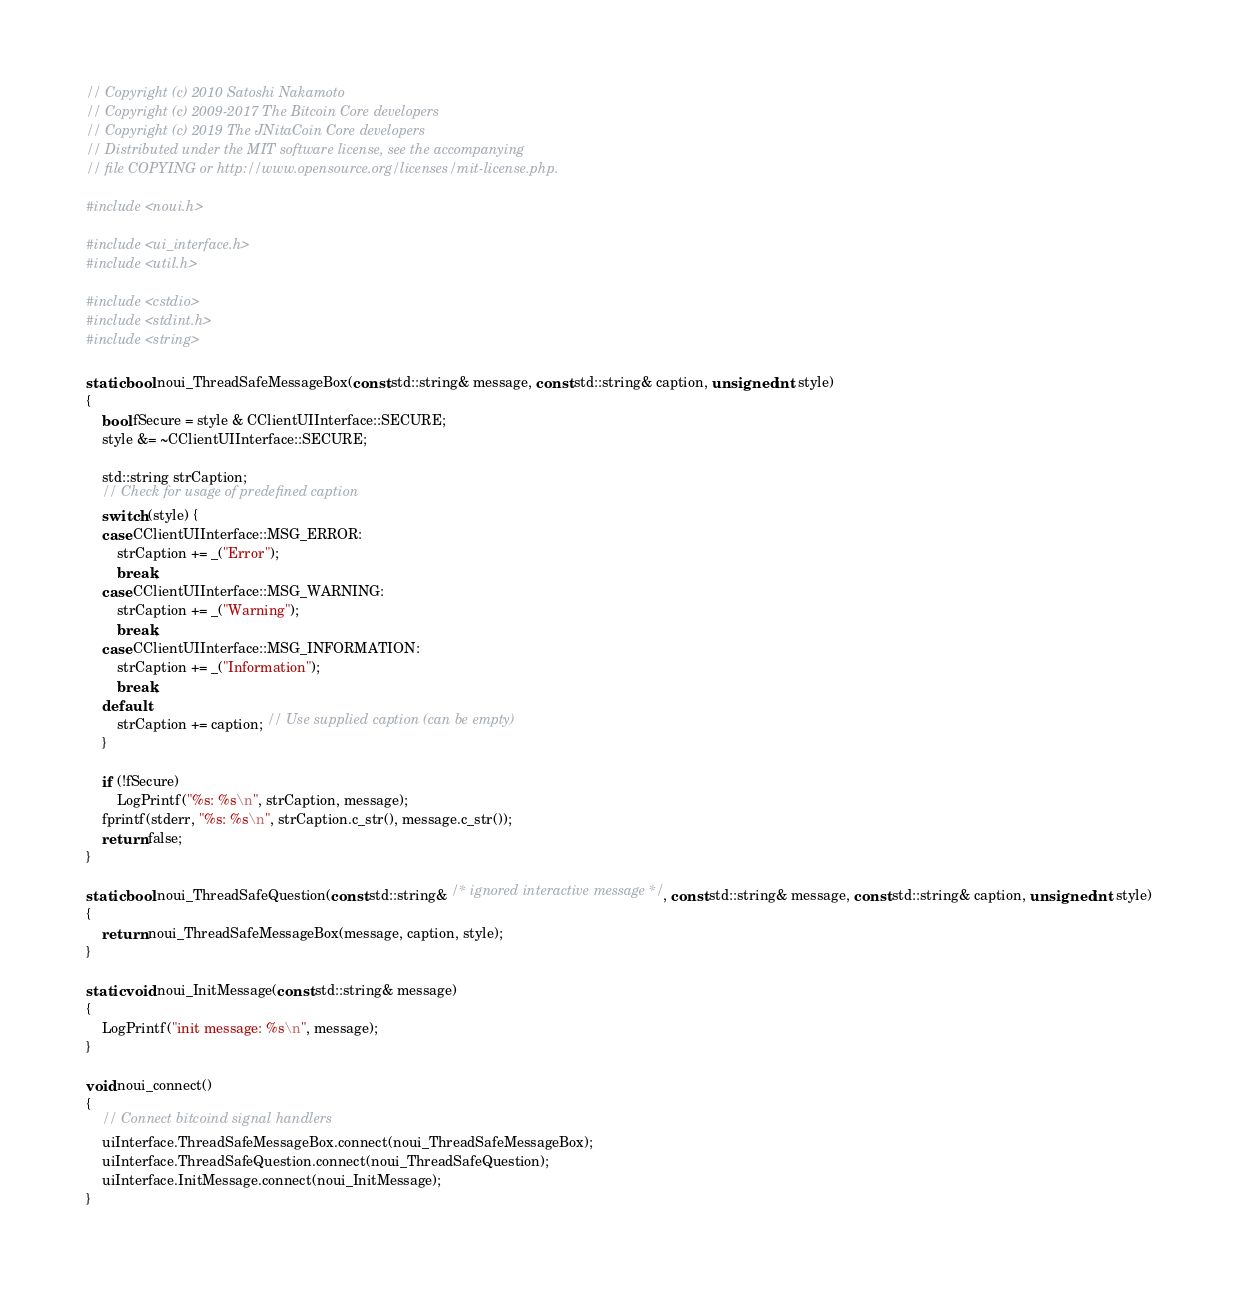<code> <loc_0><loc_0><loc_500><loc_500><_C++_>// Copyright (c) 2010 Satoshi Nakamoto
// Copyright (c) 2009-2017 The Bitcoin Core developers
// Copyright (c) 2019 The JNitaCoin Core developers
// Distributed under the MIT software license, see the accompanying
// file COPYING or http://www.opensource.org/licenses/mit-license.php.

#include <noui.h>

#include <ui_interface.h>
#include <util.h>

#include <cstdio>
#include <stdint.h>
#include <string>

static bool noui_ThreadSafeMessageBox(const std::string& message, const std::string& caption, unsigned int style)
{
    bool fSecure = style & CClientUIInterface::SECURE;
    style &= ~CClientUIInterface::SECURE;

    std::string strCaption;
    // Check for usage of predefined caption
    switch (style) {
    case CClientUIInterface::MSG_ERROR:
        strCaption += _("Error");
        break;
    case CClientUIInterface::MSG_WARNING:
        strCaption += _("Warning");
        break;
    case CClientUIInterface::MSG_INFORMATION:
        strCaption += _("Information");
        break;
    default:
        strCaption += caption; // Use supplied caption (can be empty)
    }

    if (!fSecure)
        LogPrintf("%s: %s\n", strCaption, message);
    fprintf(stderr, "%s: %s\n", strCaption.c_str(), message.c_str());
    return false;
}

static bool noui_ThreadSafeQuestion(const std::string& /* ignored interactive message */, const std::string& message, const std::string& caption, unsigned int style)
{
    return noui_ThreadSafeMessageBox(message, caption, style);
}

static void noui_InitMessage(const std::string& message)
{
    LogPrintf("init message: %s\n", message);
}

void noui_connect()
{
    // Connect bitcoind signal handlers
    uiInterface.ThreadSafeMessageBox.connect(noui_ThreadSafeMessageBox);
    uiInterface.ThreadSafeQuestion.connect(noui_ThreadSafeQuestion);
    uiInterface.InitMessage.connect(noui_InitMessage);
}
</code> 